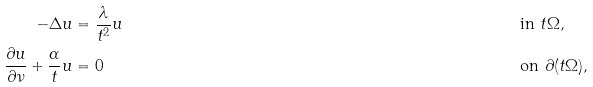Convert formula to latex. <formula><loc_0><loc_0><loc_500><loc_500>- \Delta u & = \frac { \lambda } { t ^ { 2 } } u & \quad & \text {in $t\Omega$} , \\ \frac { \partial u } { \partial \nu } + \frac { \alpha } { t } u & = 0 & & \text {on $\partial (t\Omega)$} ,</formula> 